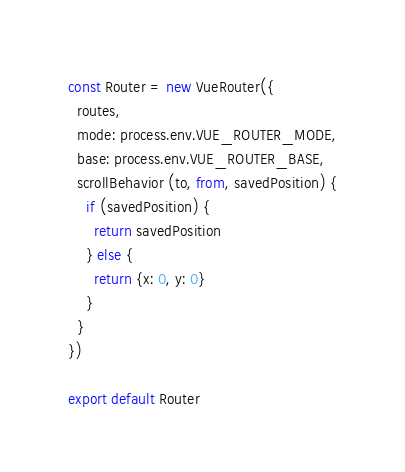Convert code to text. <code><loc_0><loc_0><loc_500><loc_500><_JavaScript_>const Router = new VueRouter({
  routes,
  mode: process.env.VUE_ROUTER_MODE,
  base: process.env.VUE_ROUTER_BASE,
  scrollBehavior (to, from, savedPosition) {
    if (savedPosition) {
      return savedPosition
    } else {
      return {x: 0, y: 0}
    }
  }
})

export default Router
</code> 